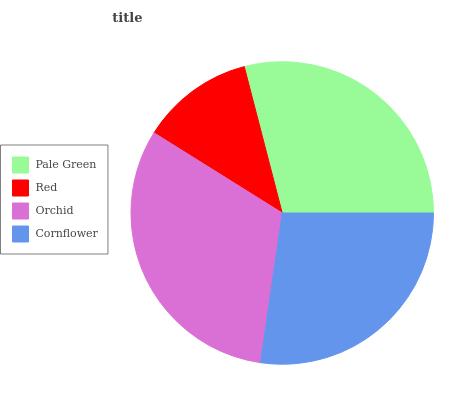Is Red the minimum?
Answer yes or no. Yes. Is Orchid the maximum?
Answer yes or no. Yes. Is Orchid the minimum?
Answer yes or no. No. Is Red the maximum?
Answer yes or no. No. Is Orchid greater than Red?
Answer yes or no. Yes. Is Red less than Orchid?
Answer yes or no. Yes. Is Red greater than Orchid?
Answer yes or no. No. Is Orchid less than Red?
Answer yes or no. No. Is Pale Green the high median?
Answer yes or no. Yes. Is Cornflower the low median?
Answer yes or no. Yes. Is Red the high median?
Answer yes or no. No. Is Orchid the low median?
Answer yes or no. No. 